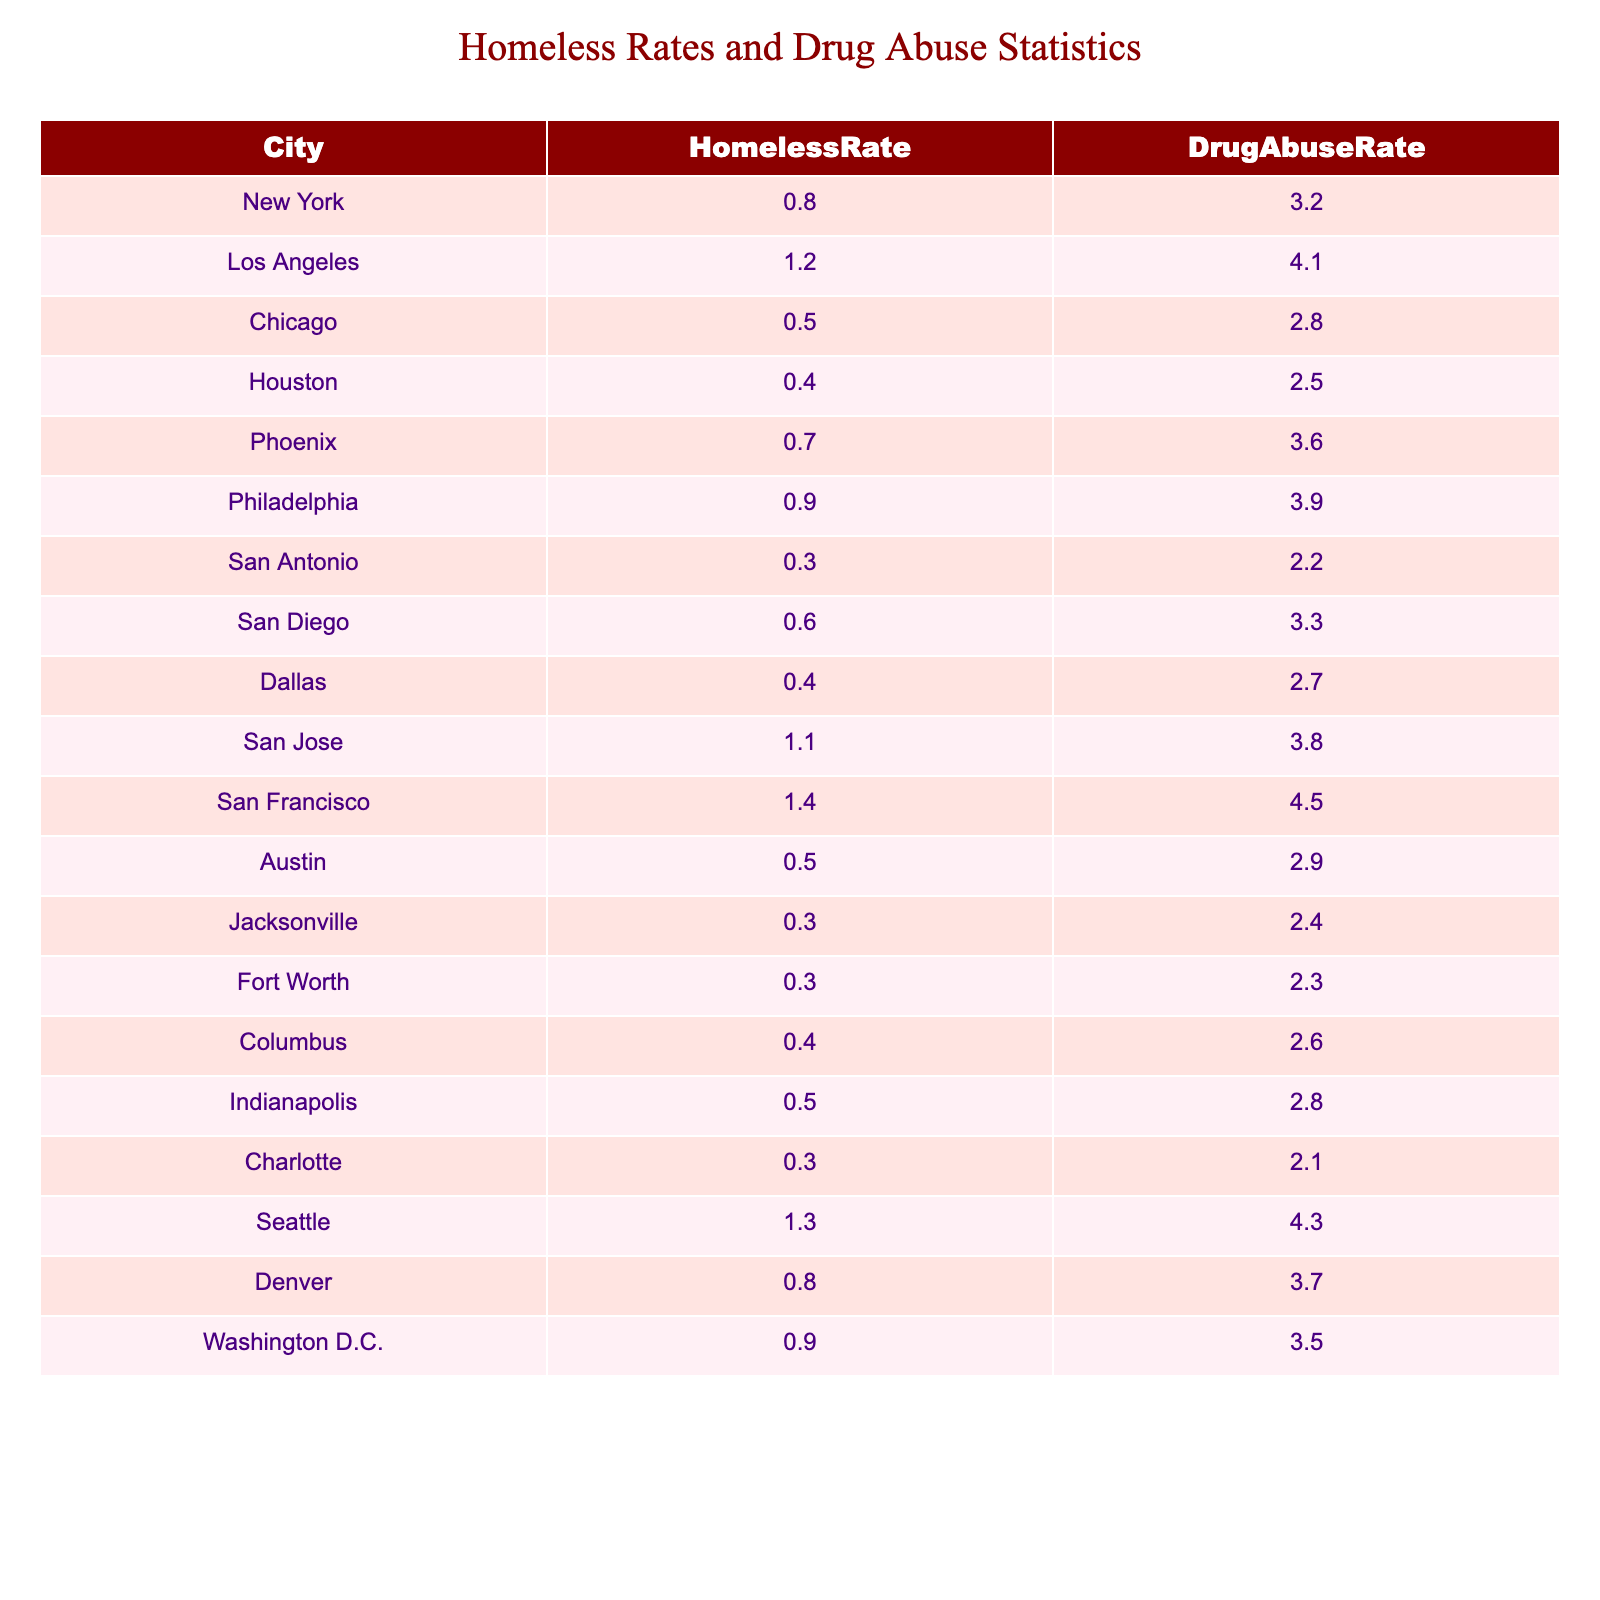What city has the highest homeless rate? By examining the "HomelessRate" column in the table, I can see that San Francisco has the highest value at 1.4.
Answer: San Francisco What is the drug abuse rate in Houston? Looking at the "DrugAbuseRate" column for Houston, the value listed is 2.5.
Answer: 2.5 Which city has a homeless rate of 0.3? Checking the "HomelessRate" column, I find that San Antonio, Jacksonville, and Fort Worth all have a homeless rate of 0.3.
Answer: San Antonio, Jacksonville, Fort Worth What is the difference between the highest and lowest drug abuse rates? The highest drug abuse rate is 4.5 (San Francisco), and the lowest is 2.1 (Charlotte). The difference is calculated as 4.5 - 2.1 = 2.4.
Answer: 2.4 Is the homeless rate in Seattle higher than in San Diego? The homeless rate for Seattle is 1.3, while for San Diego it is 0.6. Since 1.3 is greater than 0.6, the answer is yes.
Answer: Yes What is the average homeless rate across these cities? To calculate the average, I sum all the homeless rates (0.8 + 1.2 + 0.5 + 0.4 + 0.7 + 0.9 + 0.3 + 0.6 + 0.4 + 1.1 + 1.4 + 0.5 + 0.3 + 0.3 + 0.4 + 0.5 + 0.3 + 1.3 + 0.8 + 0.9) = 12.5, and since there are 20 cities, the average is 12.5 / 20 = 0.625.
Answer: 0.625 Which city has a drug abuse rate greater than 4? By reviewing the "DrugAbuseRate" column, I identify San Francisco (4.5) and Los Angeles (4.1) as cities with drug abuse rates greater than 4.
Answer: San Francisco, Los Angeles What is the ratio of the drug abuse rate to the homeless rate for Chicago? For Chicago, the drug abuse rate is 2.8 and the homeless rate is 0.5. The ratio is calculated as 2.8 / 0.5 = 5.6.
Answer: 5.6 Is there a city where the homeless rate and drug abuse rate are equal? Reviewing the values in the table, none of the cities show an equal homeless rate and drug abuse rate; thus, it is false.
Answer: No What is the total drug abuse rate for all cities with a homeless rate over 1? First, I find the cities with a homeless rate over 1. These cities are San Francisco (4.5), Seattle (4.3), San Jose (3.8), and Los Angeles (4.1). The total is calculated as 4.5 + 4.3 + 3.8 + 4.1 = 16.7.
Answer: 16.7 